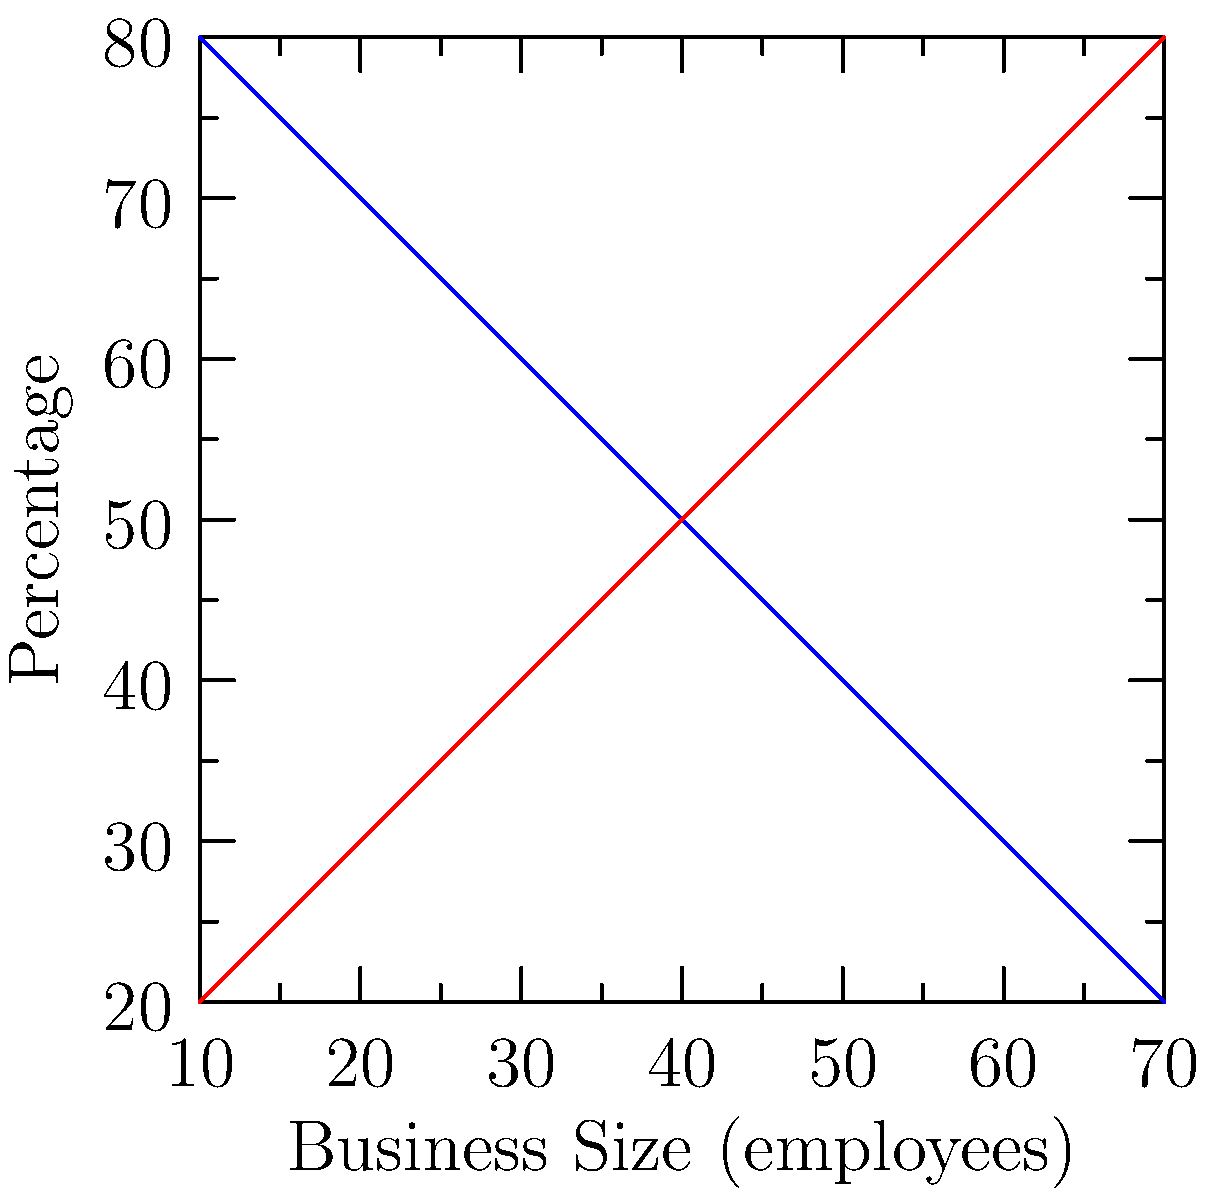As a local government official supporting family-owned businesses, you're analyzing a dataset of storefront images classified by business type and size. The graph shows the relationship between business size and ownership type. What size range of businesses should you focus on to maximize support for family-owned enterprises? To determine the optimal size range for supporting family-owned businesses, let's analyze the graph step-by-step:

1. The x-axis represents business size in terms of number of employees, ranging from 10 to 70.
2. The y-axis shows the percentage of businesses that are family-owned or corporate.
3. The blue line represents family-owned businesses, while the red line represents corporate businesses.
4. As business size increases, the percentage of family-owned businesses decreases, and the percentage of corporate businesses increases.
5. The lines intersect at around 40 employees, indicating a 50-50 split between family-owned and corporate businesses at this point.
6. To maximize support for family-owned businesses, we should focus on the range where they have the highest representation.
7. The graph shows that family-owned businesses have the highest percentage (80%) at the smallest size (10 employees).
8. The percentage of family-owned businesses remains higher than corporate businesses up to the intersection point (40 employees).

Therefore, to maximize support for family-owned enterprises, you should focus on businesses with fewer than 40 employees, with a particular emphasis on very small businesses (10-25 employees) where family ownership is most prevalent.
Answer: Businesses with fewer than 40 employees, especially those with 10-25 employees. 